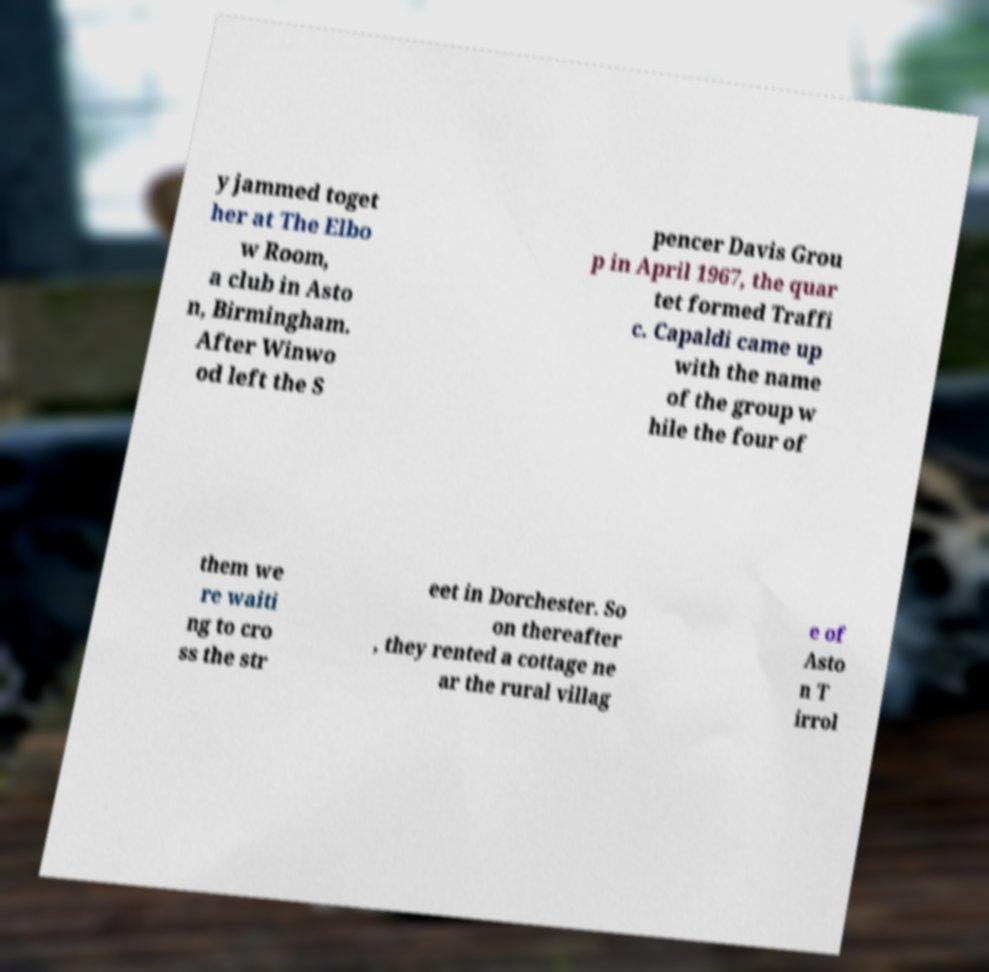There's text embedded in this image that I need extracted. Can you transcribe it verbatim? y jammed toget her at The Elbo w Room, a club in Asto n, Birmingham. After Winwo od left the S pencer Davis Grou p in April 1967, the quar tet formed Traffi c. Capaldi came up with the name of the group w hile the four of them we re waiti ng to cro ss the str eet in Dorchester. So on thereafter , they rented a cottage ne ar the rural villag e of Asto n T irrol 